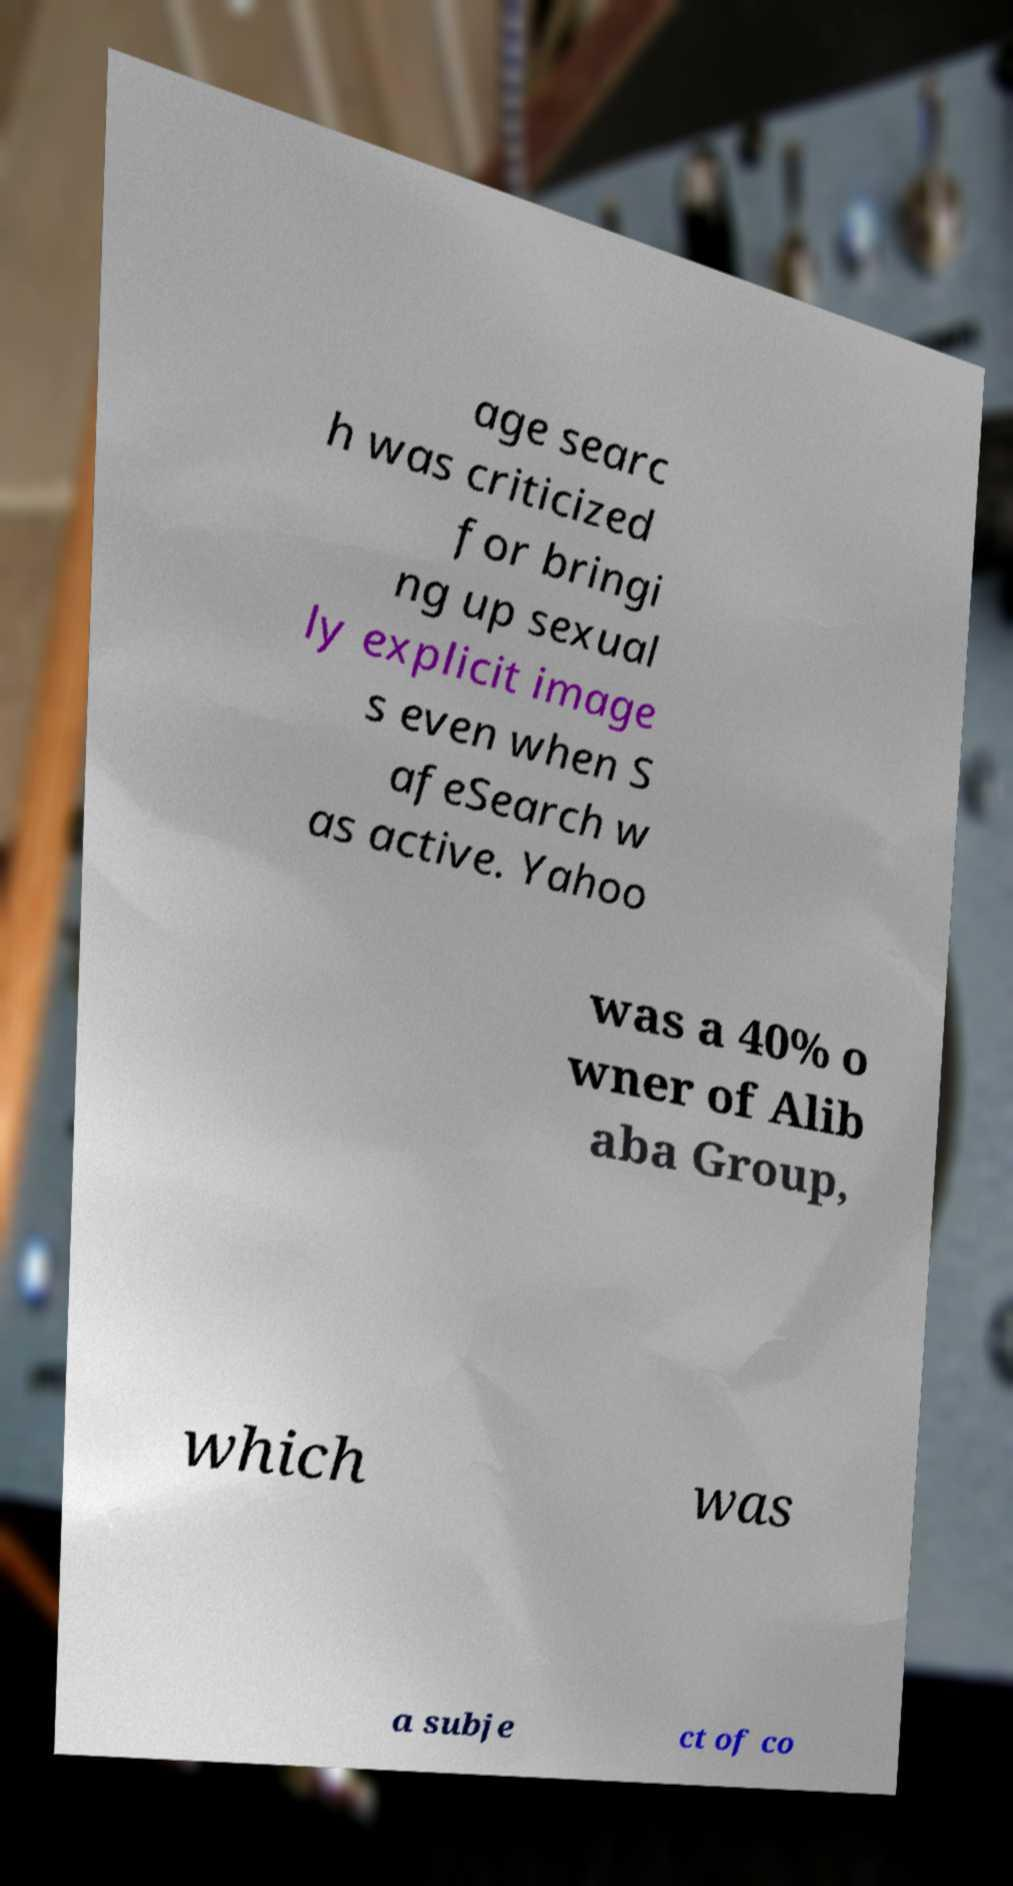Please read and relay the text visible in this image. What does it say? age searc h was criticized for bringi ng up sexual ly explicit image s even when S afeSearch w as active. Yahoo was a 40% o wner of Alib aba Group, which was a subje ct of co 